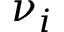Convert formula to latex. <formula><loc_0><loc_0><loc_500><loc_500>\nu _ { i }</formula> 